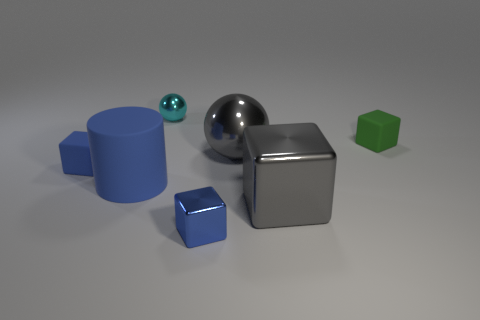Add 1 big cylinders. How many objects exist? 8 Subtract all tiny blue matte blocks. How many blocks are left? 3 Subtract all green blocks. How many blocks are left? 3 Subtract all gray balls. How many gray blocks are left? 1 Subtract all large red metal things. Subtract all small blue metallic blocks. How many objects are left? 6 Add 6 metal spheres. How many metal spheres are left? 8 Add 3 small yellow cylinders. How many small yellow cylinders exist? 3 Subtract 1 green cubes. How many objects are left? 6 Subtract all balls. How many objects are left? 5 Subtract 1 cylinders. How many cylinders are left? 0 